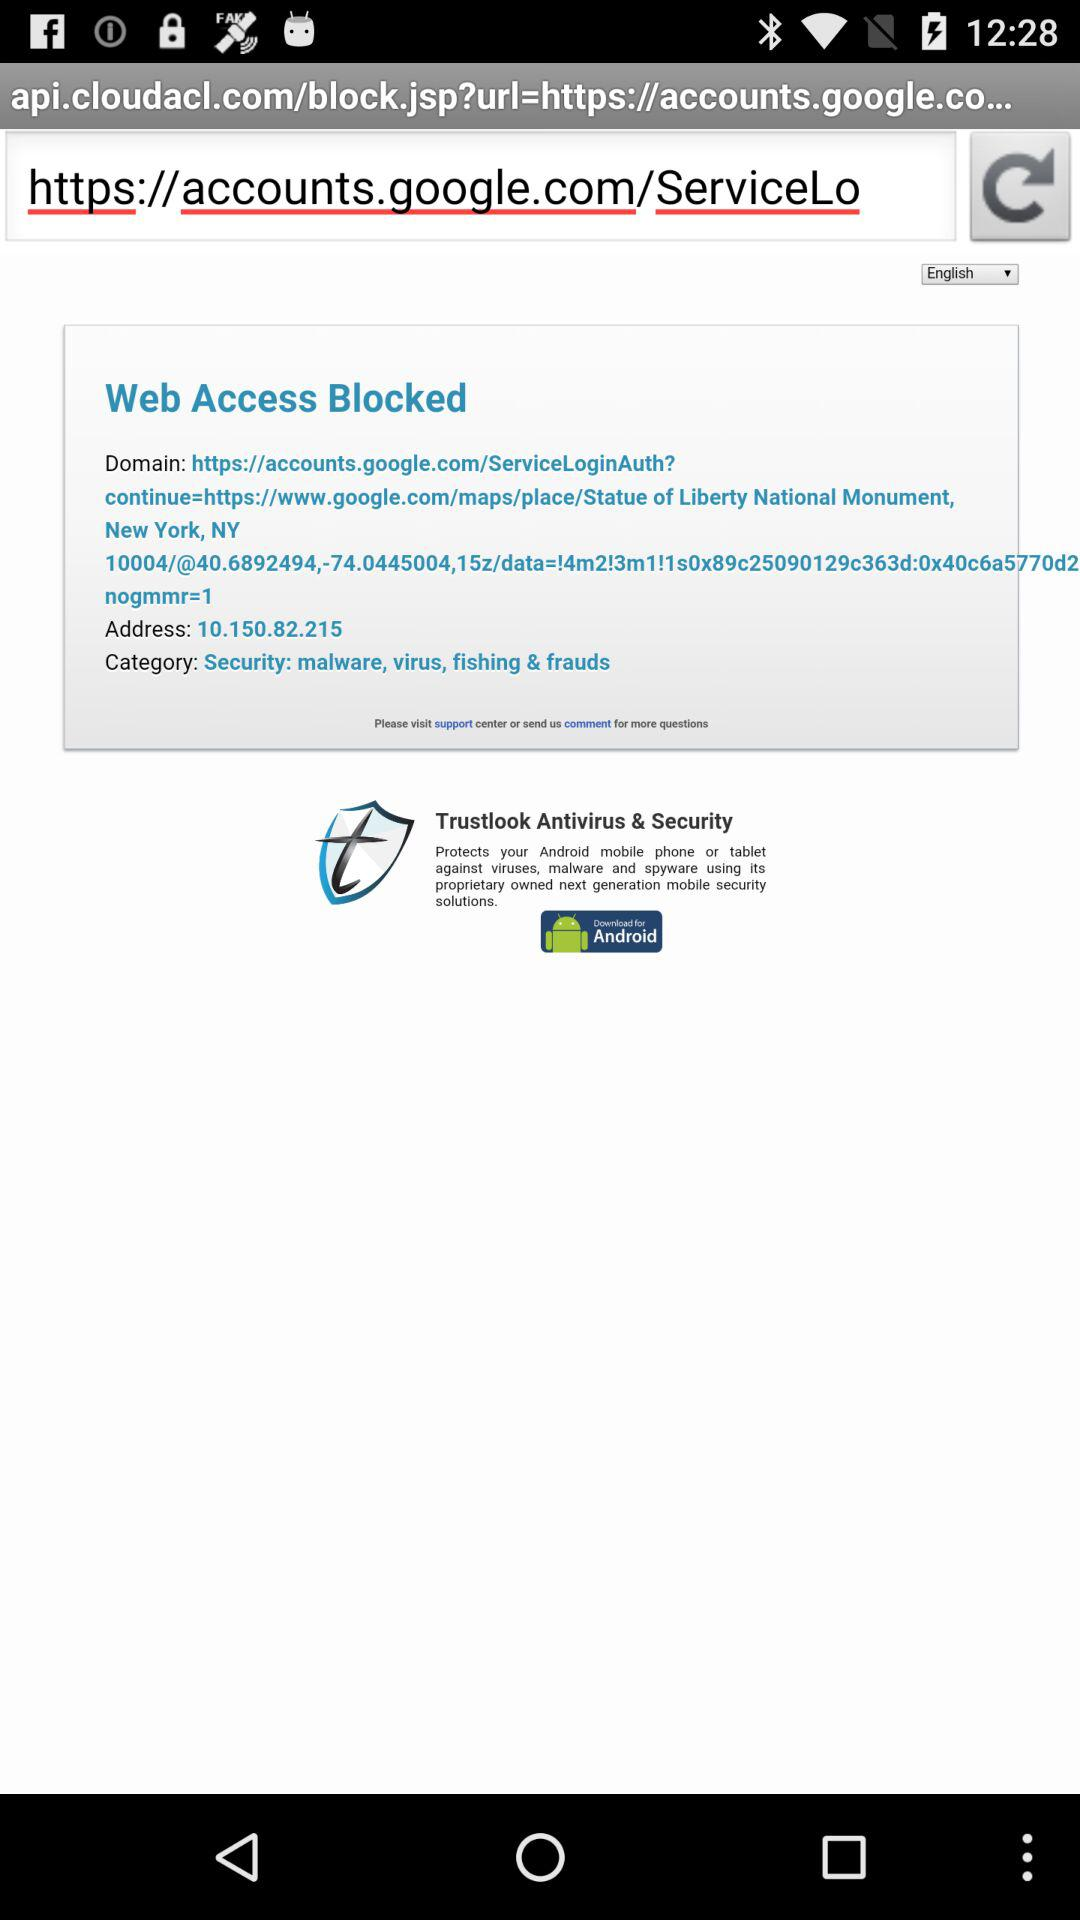What is the address? The address is 10.150.82.215. 